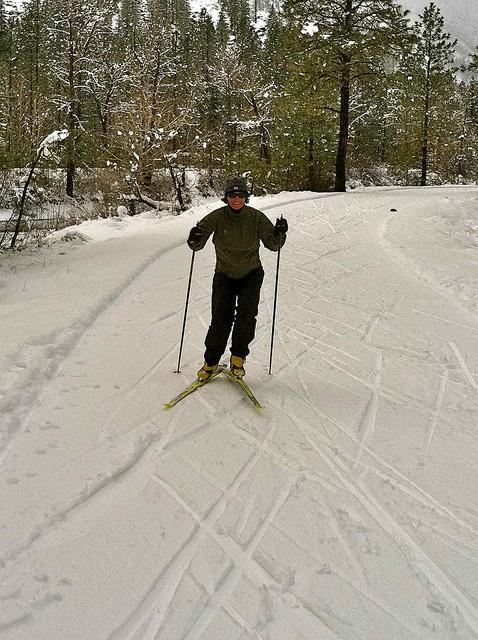Is the person cold?
Write a very short answer. Yes. Is the person moving?
Answer briefly. Yes. What color is the snow?
Keep it brief. White. What is the man doing?
Quick response, please. Skiing. Why is there a crisscross pattern in the snow?
Quick response, please. Skiers. Which direction is the sun?
Keep it brief. West. What is on the ground?
Quick response, please. Snow. 